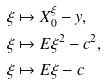Convert formula to latex. <formula><loc_0><loc_0><loc_500><loc_500>\xi & \mapsto X _ { 0 } ^ { \xi } - y , \\ \xi & \mapsto E \xi ^ { 2 } - c ^ { 2 } , \\ \xi & \mapsto E \xi - c</formula> 